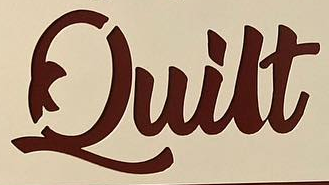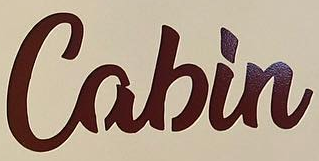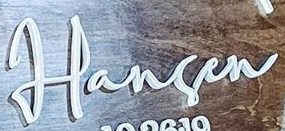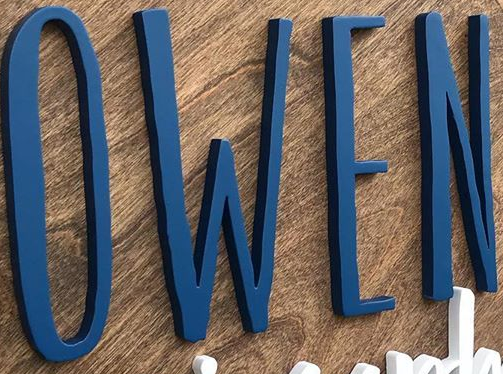What text is displayed in these images sequentially, separated by a semicolon? Quilt; Cabin; Harsen; OWEN 